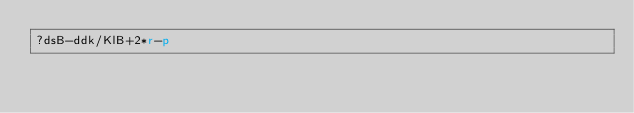<code> <loc_0><loc_0><loc_500><loc_500><_dc_>?dsB-ddk/KlB+2*r-p</code> 